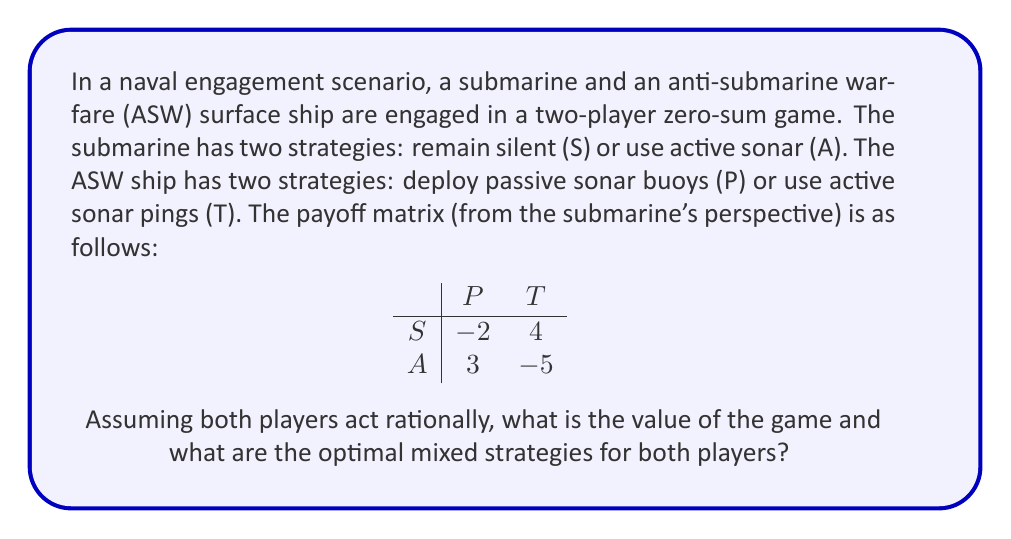Show me your answer to this math problem. To solve this two-player zero-sum game, we'll use the minimax theorem and solve for mixed strategies.

1. Let's define the variables:
   $x$: probability of submarine choosing S
   $1-x$: probability of submarine choosing A
   $y$: probability of ASW ship choosing P
   $1-y$: probability of ASW ship choosing T

2. Set up the expected value equations:
   For submarine strategy S: $E(S) = -2y + 4(1-y) = 4 - 6y$
   For submarine strategy A: $E(A) = 3y + (-5)(1-y) = 8y - 5$

3. For the optimal mixed strategy, these expected values should be equal:
   $4 - 6y = 8y - 5$
   $9 = 14y$
   $y = \frac{9}{14} \approx 0.6429$

4. The ASW ship's strategy probabilities are thus:
   $P: y = \frac{9}{14}$
   $T: 1-y = \frac{5}{14}$

5. To find the submarine's optimal strategy, we equate the expected values for the ASW ship:
   $-2x + 3(1-x) = 4x + (-5)(1-x)$
   $-2x + 3 - 3x = 4x - 5 + 5x$
   $3 = 14x$
   $x = \frac{3}{14} \approx 0.2143$

6. The submarine's strategy probabilities are:
   $S: x = \frac{3}{14}$
   $A: 1-x = \frac{11}{14}$

7. The value of the game (V) can be calculated by plugging either player's probabilities into the other's expected value equation:
   $V = 4 - 6(\frac{9}{14}) = 4 - \frac{54}{14} = \frac{2}{14} \approx 0.1429$

This positive value indicates a slight advantage for the submarine.
Answer: The value of the game is $\frac{2}{14}$ or approximately 0.1429.

The optimal mixed strategies are:
Submarine: $(\frac{3}{14}, \frac{11}{14})$ for (S, A)
ASW ship: $(\frac{9}{14}, \frac{5}{14})$ for (P, T) 